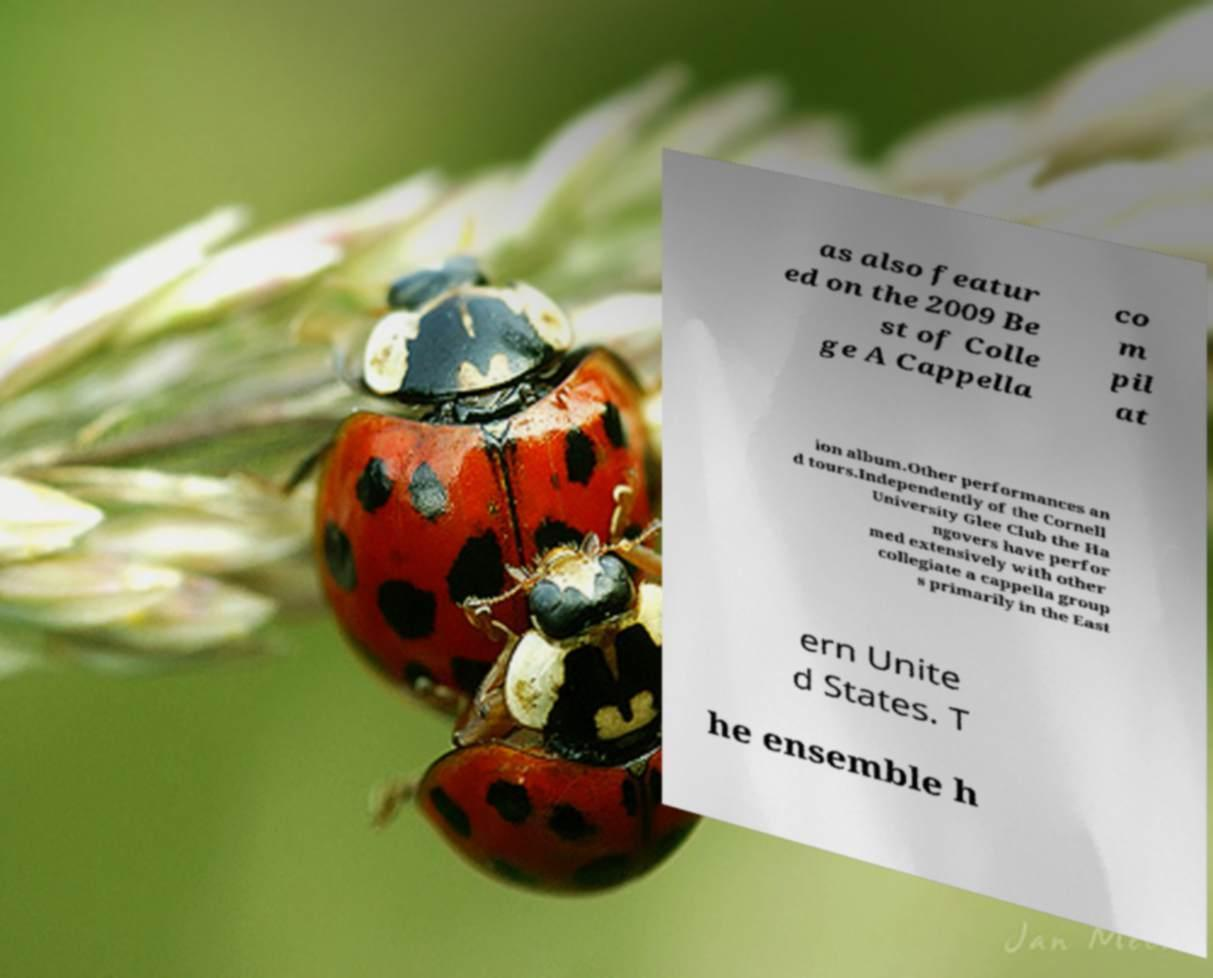Can you accurately transcribe the text from the provided image for me? as also featur ed on the 2009 Be st of Colle ge A Cappella co m pil at ion album.Other performances an d tours.Independently of the Cornell University Glee Club the Ha ngovers have perfor med extensively with other collegiate a cappella group s primarily in the East ern Unite d States. T he ensemble h 